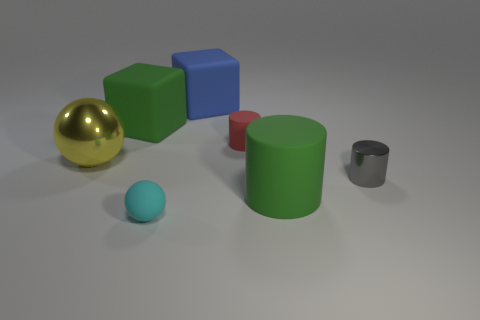Do the large matte cylinder and the large cube left of the tiny ball have the same color?
Offer a very short reply. Yes. There is a green cylinder that is the same material as the small red thing; what size is it?
Offer a terse response. Large. Are there any big things of the same color as the large rubber cylinder?
Make the answer very short. Yes. What number of things are big green rubber things in front of the tiny red object or big rubber objects?
Your answer should be compact. 3. Is the material of the tiny cyan ball the same as the small thing to the right of the red cylinder?
Make the answer very short. No. What size is the matte cube that is the same color as the large cylinder?
Ensure brevity in your answer.  Large. Are there any green cubes made of the same material as the small cyan ball?
Provide a short and direct response. Yes. What number of things are big matte objects that are behind the big green cylinder or tiny matte objects in front of the red matte cylinder?
Make the answer very short. 3. Does the blue matte thing have the same shape as the green rubber thing that is behind the gray cylinder?
Provide a succinct answer. Yes. What number of other objects are the same shape as the tiny gray thing?
Your response must be concise. 2. 